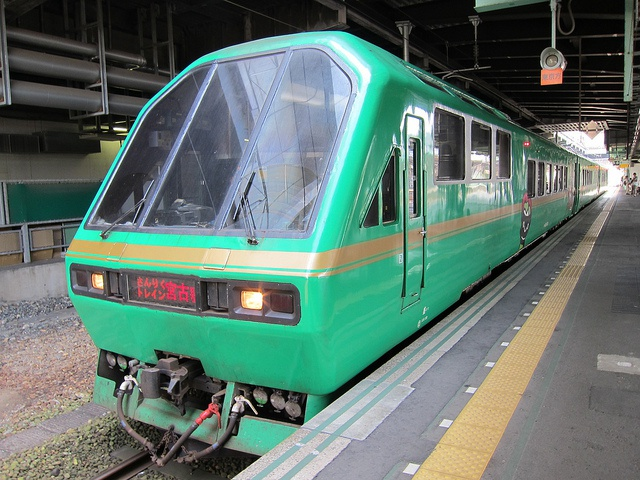Describe the objects in this image and their specific colors. I can see train in black, gray, darkgray, and turquoise tones, people in black, gray, darkgray, and maroon tones, people in black, darkgray, gray, and maroon tones, and people in black, gray, darkgray, and maroon tones in this image. 